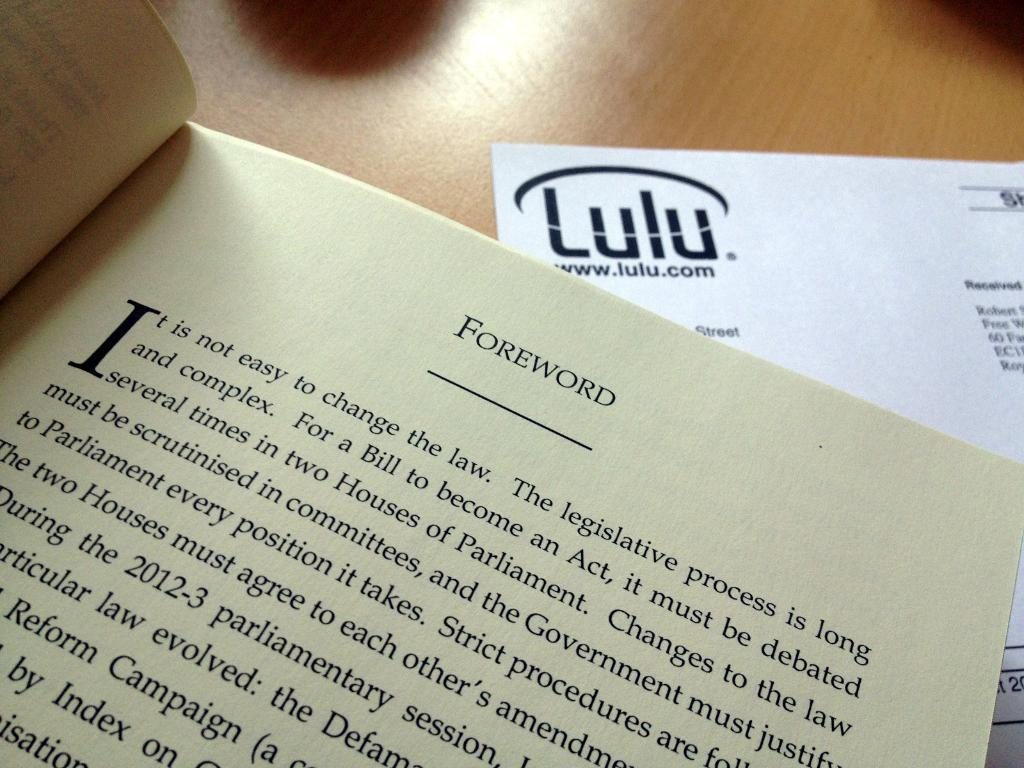<image>
Relay a brief, clear account of the picture shown. A book is open to a page titled Foreword. 